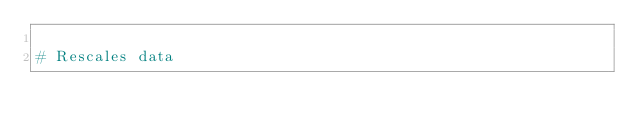<code> <loc_0><loc_0><loc_500><loc_500><_Python_>
# Rescales data</code> 